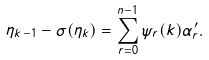Convert formula to latex. <formula><loc_0><loc_0><loc_500><loc_500>\eta _ { k - 1 } - \sigma ( \eta _ { k } ) = \sum _ { r = 0 } ^ { n - 1 } \psi _ { r } ( k ) \alpha _ { r } ^ { \prime } .</formula> 